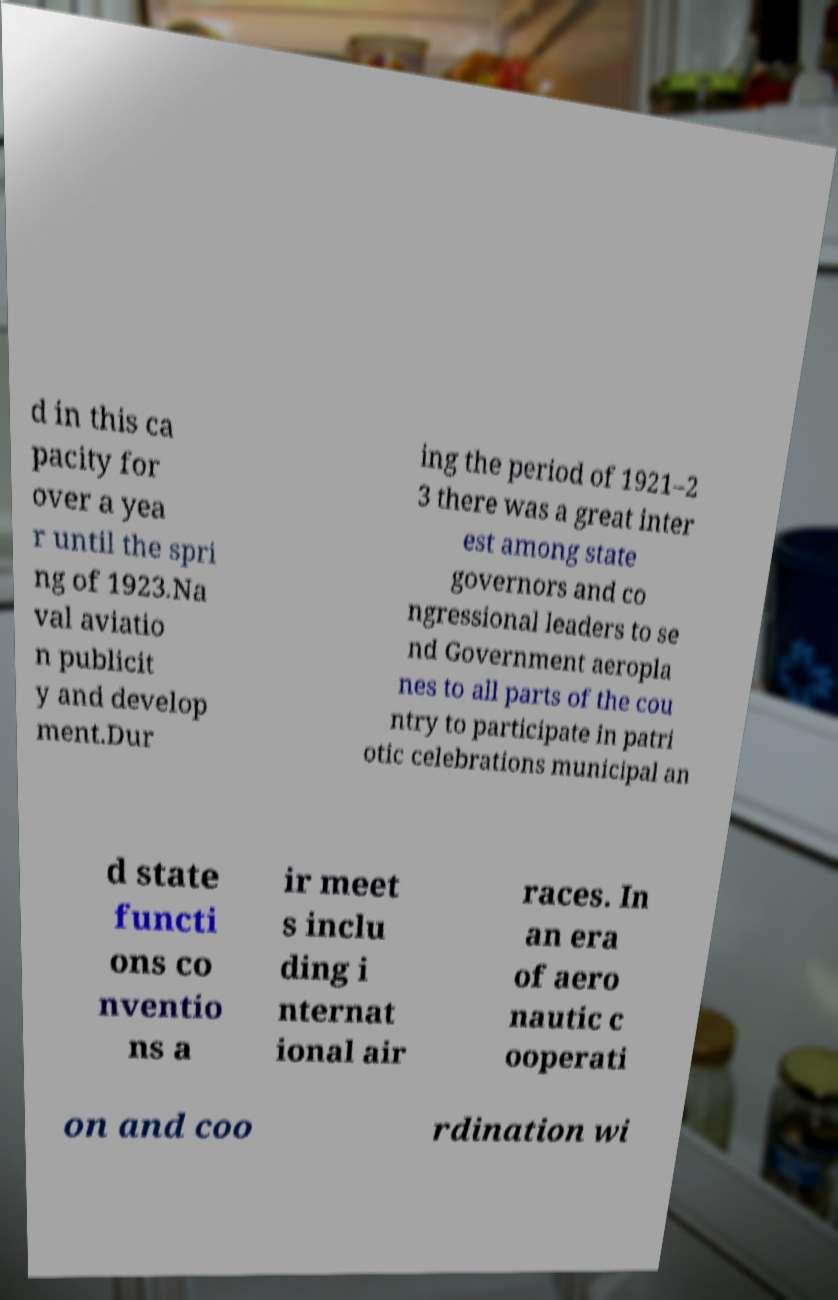For documentation purposes, I need the text within this image transcribed. Could you provide that? d in this ca pacity for over a yea r until the spri ng of 1923.Na val aviatio n publicit y and develop ment.Dur ing the period of 1921–2 3 there was a great inter est among state governors and co ngressional leaders to se nd Government aeropla nes to all parts of the cou ntry to participate in patri otic celebrations municipal an d state functi ons co nventio ns a ir meet s inclu ding i nternat ional air races. In an era of aero nautic c ooperati on and coo rdination wi 